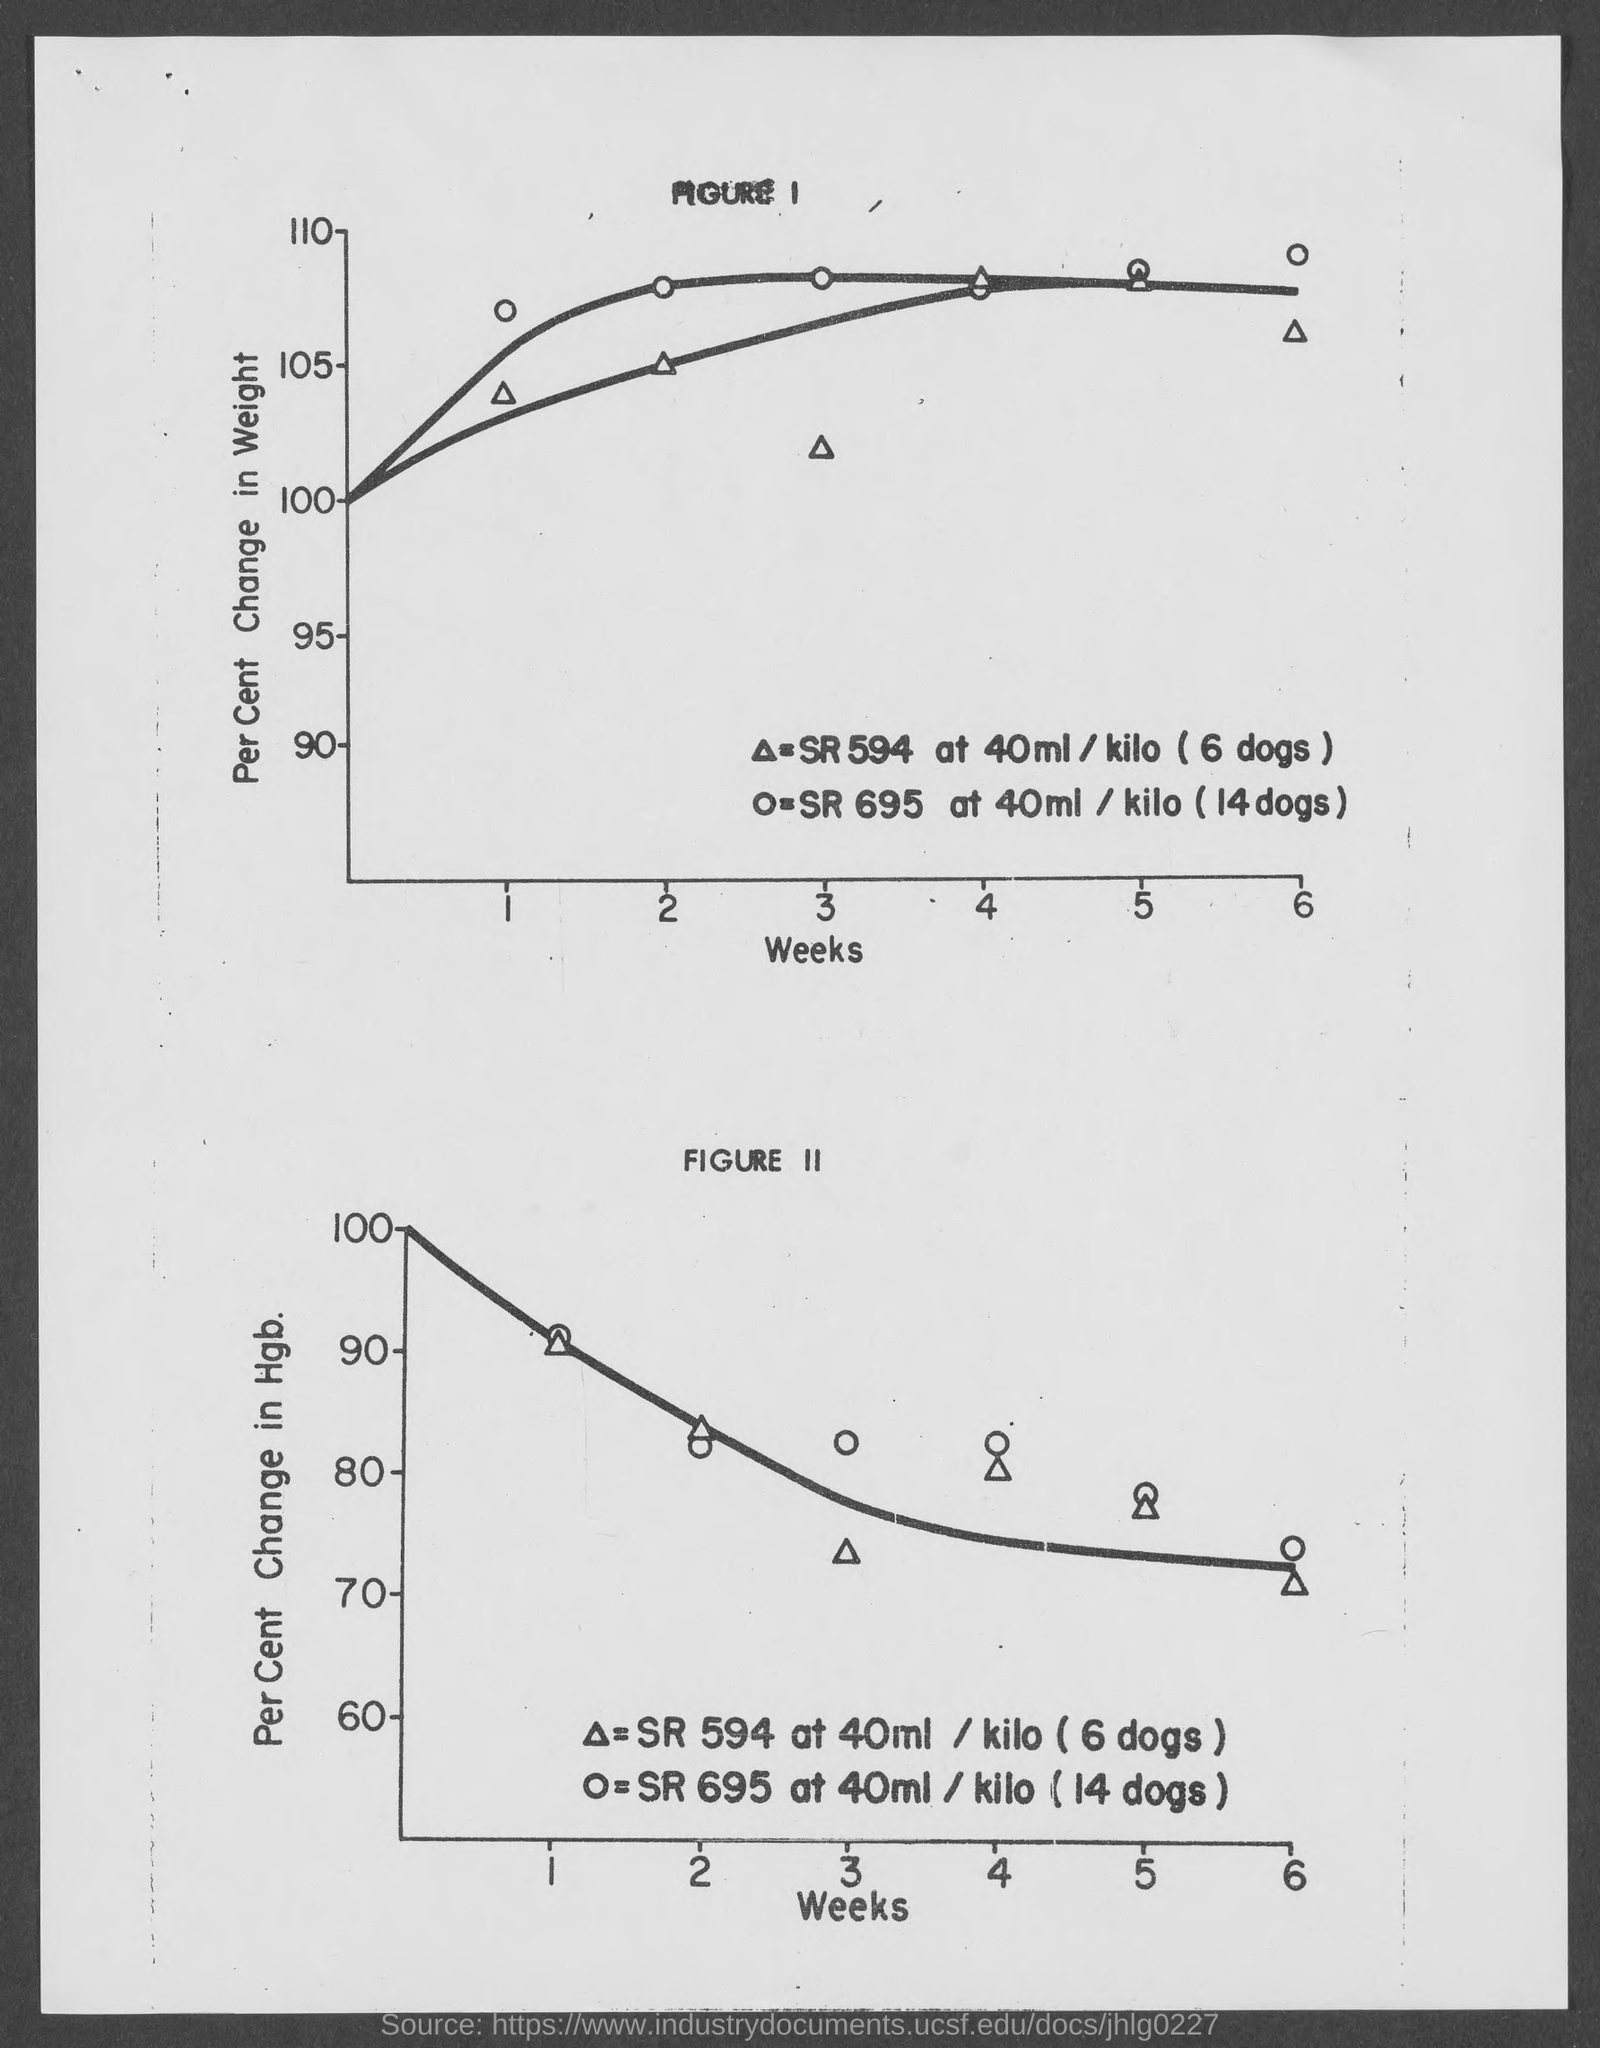What is on the horizontal axis of figure 1?
Provide a short and direct response. Weeks. What is on the horizontal axis of figure 2?
Provide a short and direct response. Weeks. What is on the vertical axis of figure 1?
Your answer should be very brief. Per cent change in weight. 